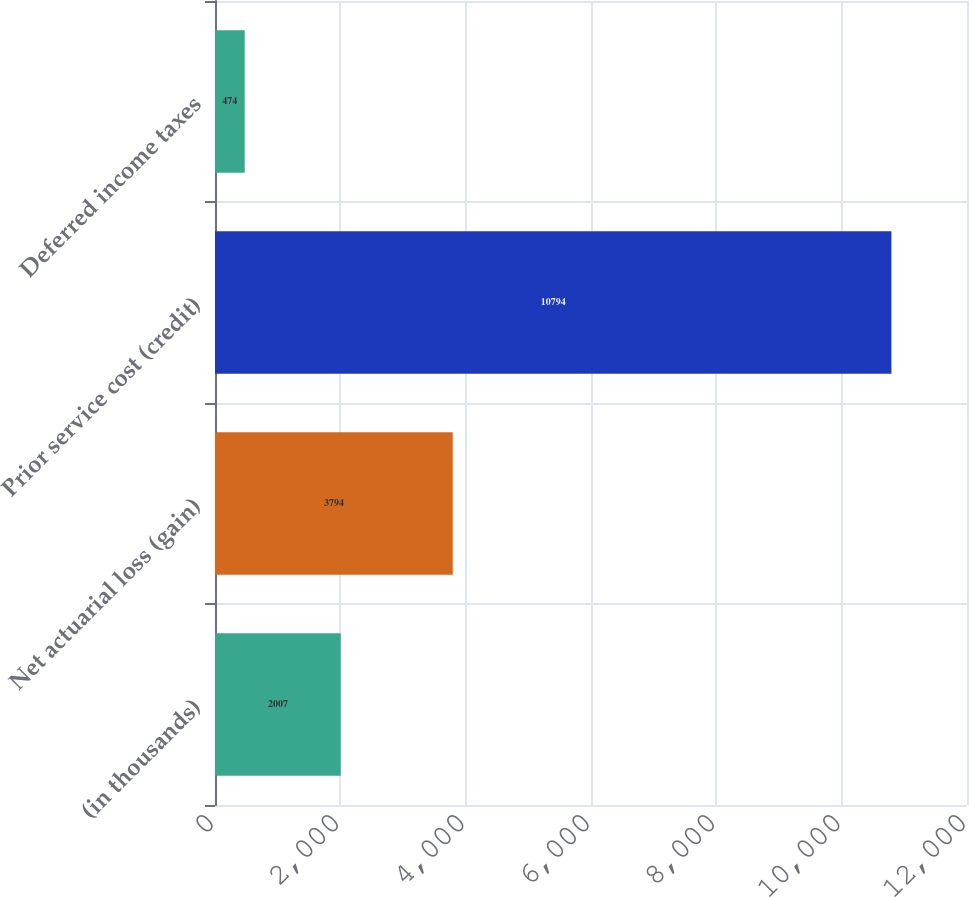Convert chart. <chart><loc_0><loc_0><loc_500><loc_500><bar_chart><fcel>(in thousands)<fcel>Net actuarial loss (gain)<fcel>Prior service cost (credit)<fcel>Deferred income taxes<nl><fcel>2007<fcel>3794<fcel>10794<fcel>474<nl></chart> 